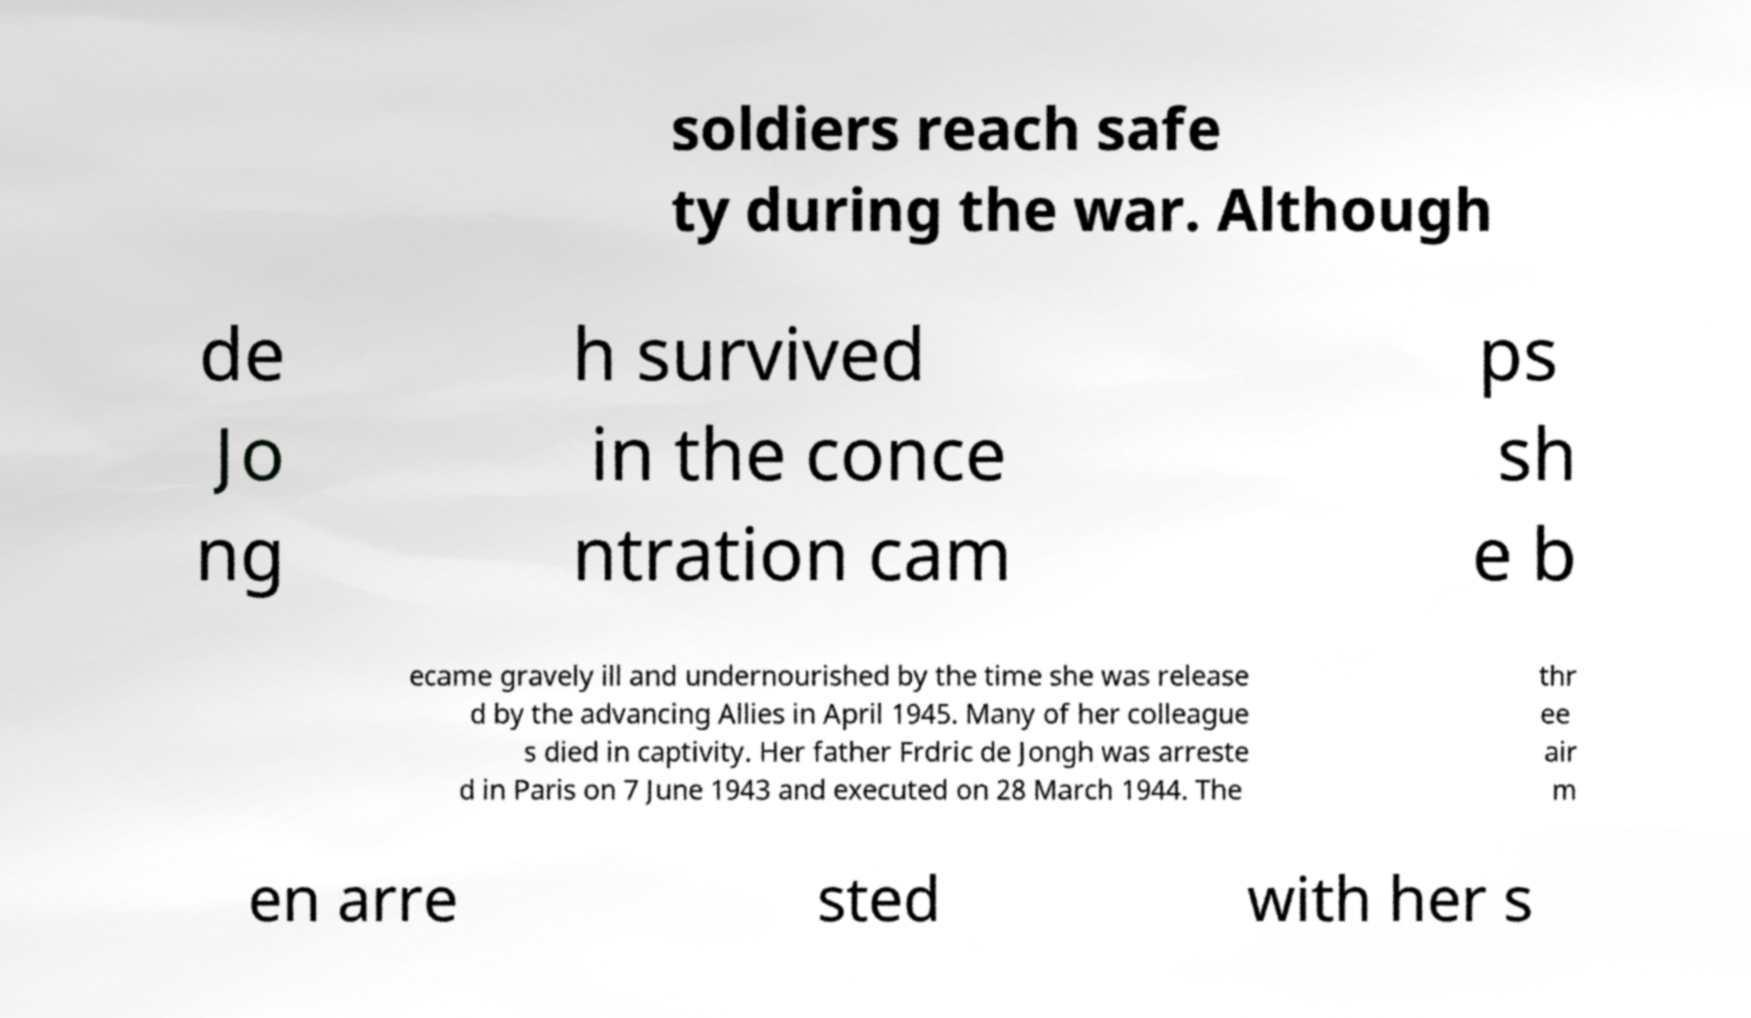Please identify and transcribe the text found in this image. soldiers reach safe ty during the war. Although de Jo ng h survived in the conce ntration cam ps sh e b ecame gravely ill and undernourished by the time she was release d by the advancing Allies in April 1945. Many of her colleague s died in captivity. Her father Frdric de Jongh was arreste d in Paris on 7 June 1943 and executed on 28 March 1944. The thr ee air m en arre sted with her s 